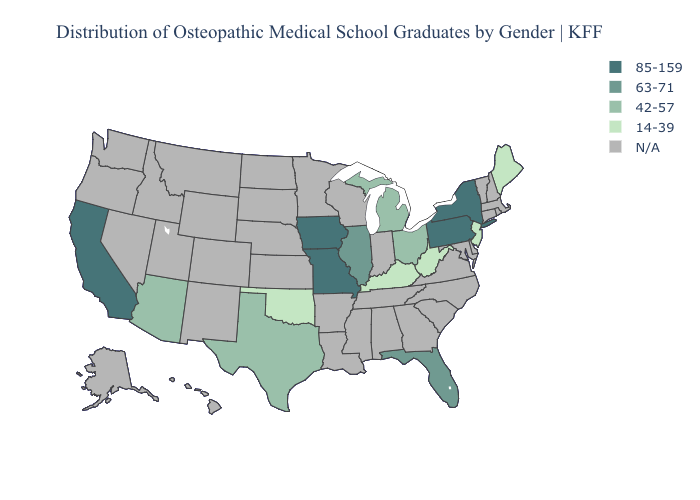Which states have the lowest value in the South?
Concise answer only. Kentucky, Oklahoma, West Virginia. What is the value of Washington?
Short answer required. N/A. What is the value of Wyoming?
Keep it brief. N/A. Name the states that have a value in the range 63-71?
Concise answer only. Florida, Illinois. What is the value of Colorado?
Write a very short answer. N/A. Name the states that have a value in the range 42-57?
Short answer required. Arizona, Michigan, Ohio, Texas. What is the value of New Hampshire?
Write a very short answer. N/A. What is the lowest value in the MidWest?
Be succinct. 42-57. Which states have the lowest value in the South?
Be succinct. Kentucky, Oklahoma, West Virginia. What is the value of Alaska?
Short answer required. N/A. Does the map have missing data?
Concise answer only. Yes. What is the lowest value in the USA?
Be succinct. 14-39. 